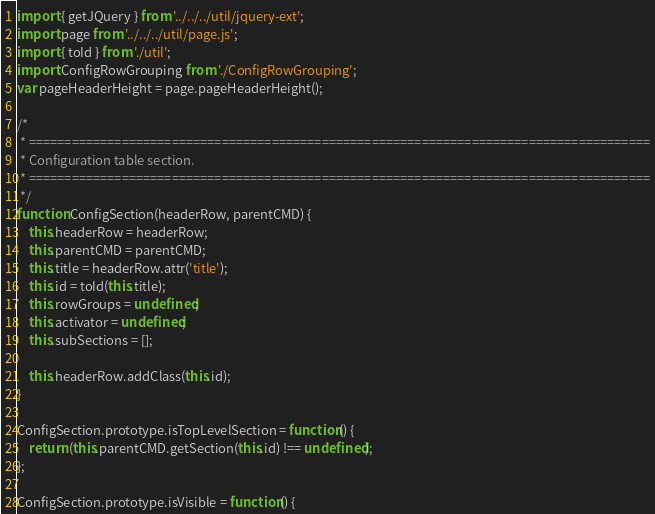Convert code to text. <code><loc_0><loc_0><loc_500><loc_500><_JavaScript_>import { getJQuery } from '../../../util/jquery-ext';
import page from '../../../util/page.js';
import { toId } from './util';
import ConfigRowGrouping from './ConfigRowGrouping';
var pageHeaderHeight = page.pageHeaderHeight();

/*
 * =======================================================================================
 * Configuration table section.
 * =======================================================================================
 */
function ConfigSection(headerRow, parentCMD) {
    this.headerRow = headerRow;
    this.parentCMD = parentCMD;
    this.title = headerRow.attr('title');
    this.id = toId(this.title);
    this.rowGroups = undefined;
    this.activator = undefined;
    this.subSections = [];

    this.headerRow.addClass(this.id);
}

ConfigSection.prototype.isTopLevelSection = function() {
    return (this.parentCMD.getSection(this.id) !== undefined);
};

ConfigSection.prototype.isVisible = function() {</code> 